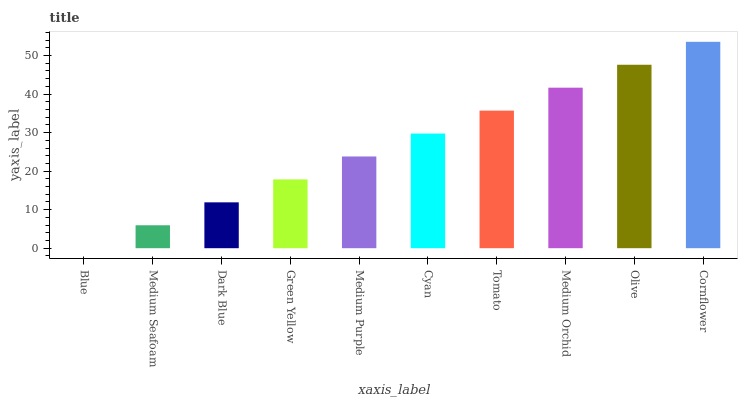Is Medium Seafoam the minimum?
Answer yes or no. No. Is Medium Seafoam the maximum?
Answer yes or no. No. Is Medium Seafoam greater than Blue?
Answer yes or no. Yes. Is Blue less than Medium Seafoam?
Answer yes or no. Yes. Is Blue greater than Medium Seafoam?
Answer yes or no. No. Is Medium Seafoam less than Blue?
Answer yes or no. No. Is Cyan the high median?
Answer yes or no. Yes. Is Medium Purple the low median?
Answer yes or no. Yes. Is Medium Purple the high median?
Answer yes or no. No. Is Medium Orchid the low median?
Answer yes or no. No. 